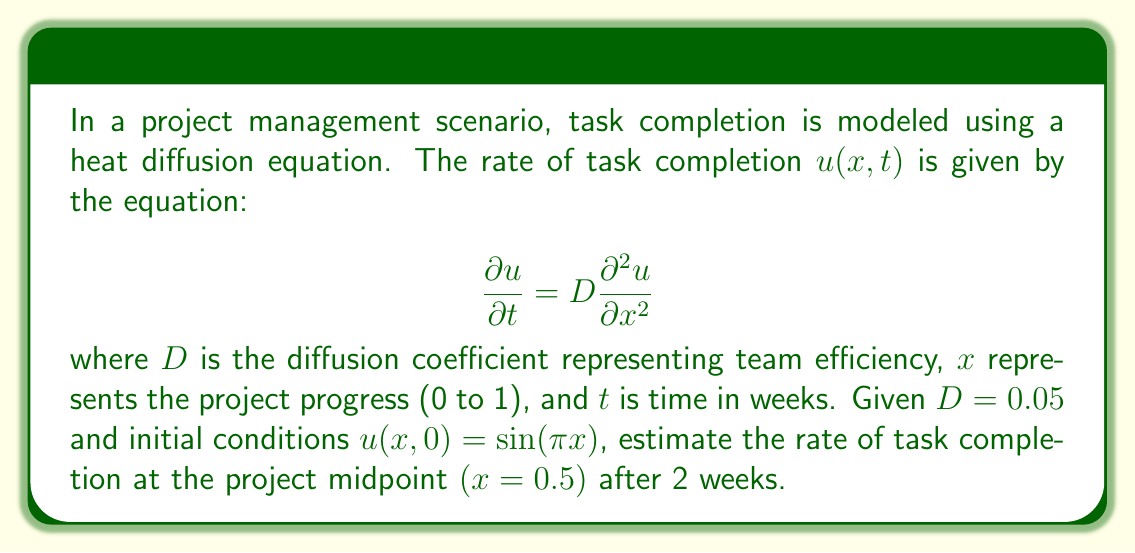Could you help me with this problem? To solve this problem, we'll use the separation of variables method:

1) The general solution for the heat equation with these boundary conditions is:

   $$u(x,t) = e^{-D\pi^2t}\sin(\pi x)$$

2) Substitute the given values:
   $D = 0.05$
   $x = 0.5$ (project midpoint)
   $t = 2$ weeks

3) Calculate:
   $$u(0.5, 2) = e^{-0.05\pi^2(2)}\sin(\pi(0.5))$$

4) Simplify:
   $$u(0.5, 2) = e^{-0.1\pi^2}\sin(\frac{\pi}{2})$$

5) $\sin(\frac{\pi}{2}) = 1$, so:
   $$u(0.5, 2) = e^{-0.1\pi^2}$$

6) Calculate the final value:
   $$u(0.5, 2) \approx 0.3678$$

This value represents the estimated rate of task completion at the project midpoint after 2 weeks, given the initial conditions and team efficiency.
Answer: 0.3678 